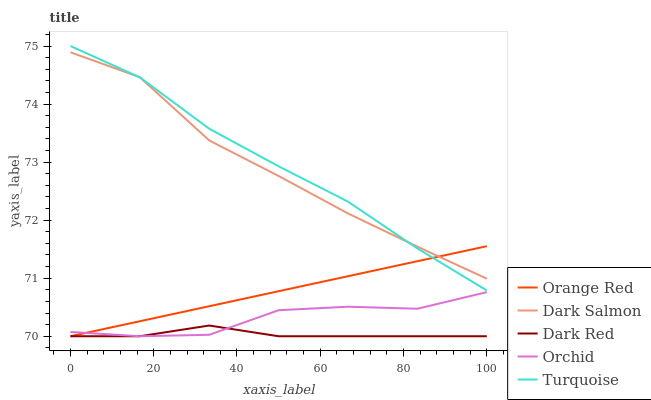Does Dark Red have the minimum area under the curve?
Answer yes or no. Yes. Does Turquoise have the maximum area under the curve?
Answer yes or no. Yes. Does Orchid have the minimum area under the curve?
Answer yes or no. No. Does Orchid have the maximum area under the curve?
Answer yes or no. No. Is Orange Red the smoothest?
Answer yes or no. Yes. Is Orchid the roughest?
Answer yes or no. Yes. Is Turquoise the smoothest?
Answer yes or no. No. Is Turquoise the roughest?
Answer yes or no. No. Does Dark Red have the lowest value?
Answer yes or no. Yes. Does Turquoise have the lowest value?
Answer yes or no. No. Does Turquoise have the highest value?
Answer yes or no. Yes. Does Orchid have the highest value?
Answer yes or no. No. Is Orchid less than Turquoise?
Answer yes or no. Yes. Is Turquoise greater than Dark Red?
Answer yes or no. Yes. Does Turquoise intersect Orange Red?
Answer yes or no. Yes. Is Turquoise less than Orange Red?
Answer yes or no. No. Is Turquoise greater than Orange Red?
Answer yes or no. No. Does Orchid intersect Turquoise?
Answer yes or no. No. 